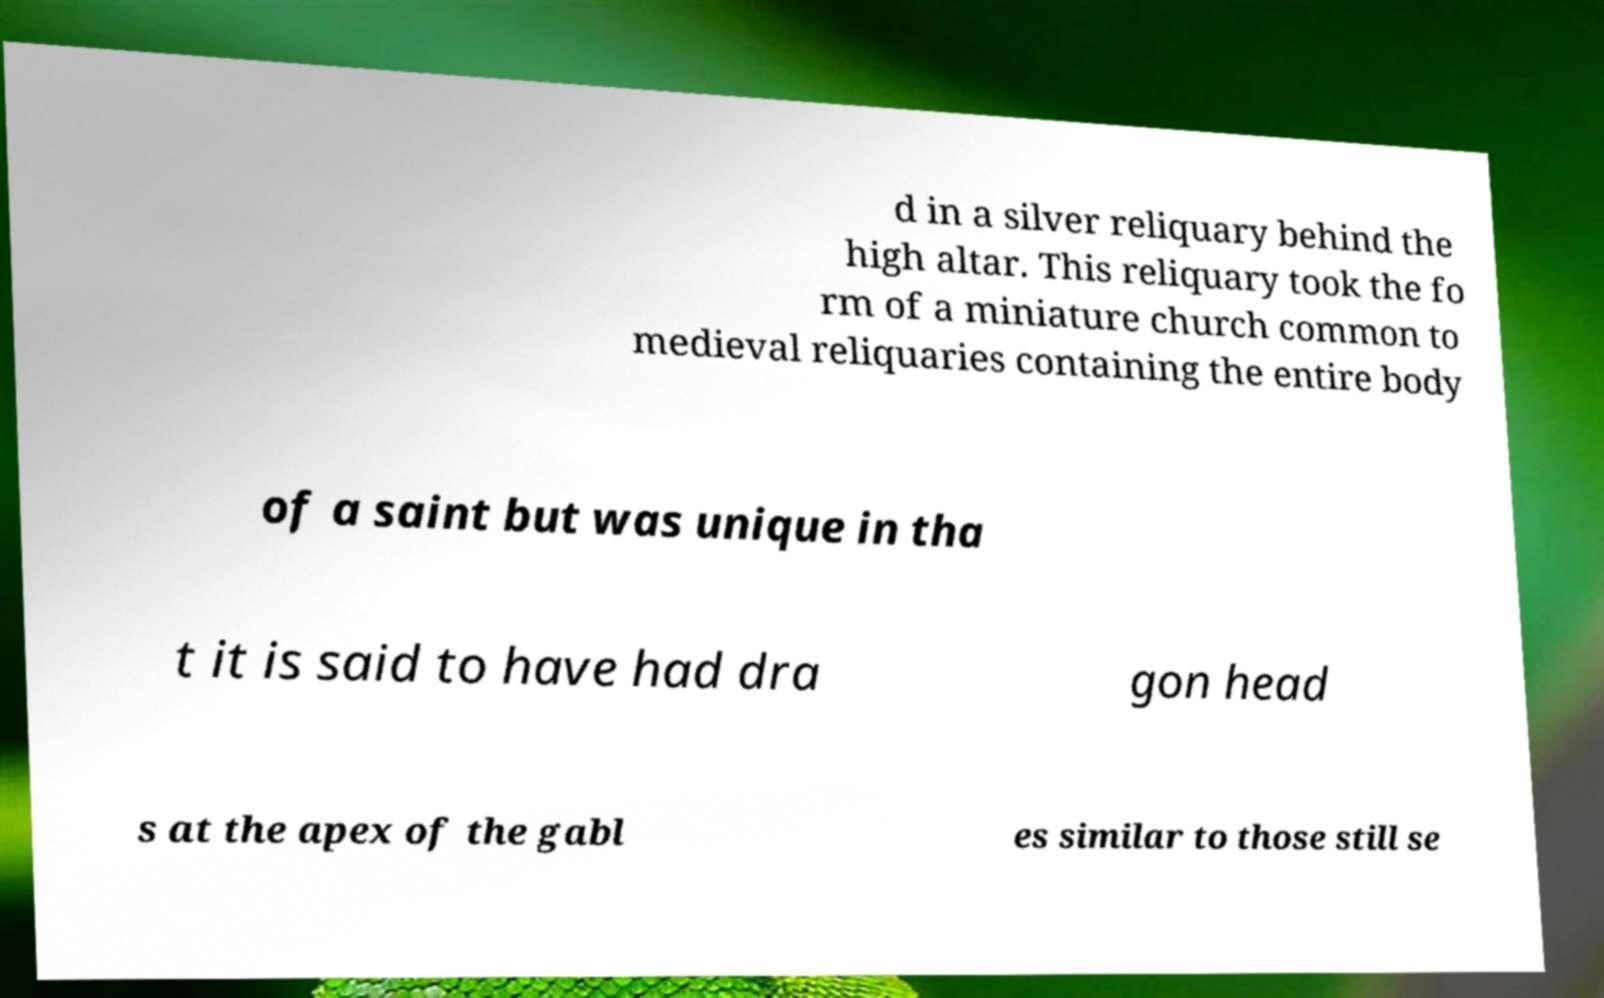What messages or text are displayed in this image? I need them in a readable, typed format. d in a silver reliquary behind the high altar. This reliquary took the fo rm of a miniature church common to medieval reliquaries containing the entire body of a saint but was unique in tha t it is said to have had dra gon head s at the apex of the gabl es similar to those still se 